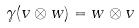<formula> <loc_0><loc_0><loc_500><loc_500>\gamma ( v \otimes w ) = w \otimes v</formula> 